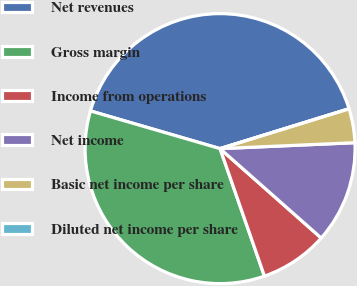Convert chart to OTSL. <chart><loc_0><loc_0><loc_500><loc_500><pie_chart><fcel>Net revenues<fcel>Gross margin<fcel>Income from operations<fcel>Net income<fcel>Basic net income per share<fcel>Diluted net income per share<nl><fcel>40.73%<fcel>34.84%<fcel>8.15%<fcel>12.22%<fcel>4.07%<fcel>0.0%<nl></chart> 